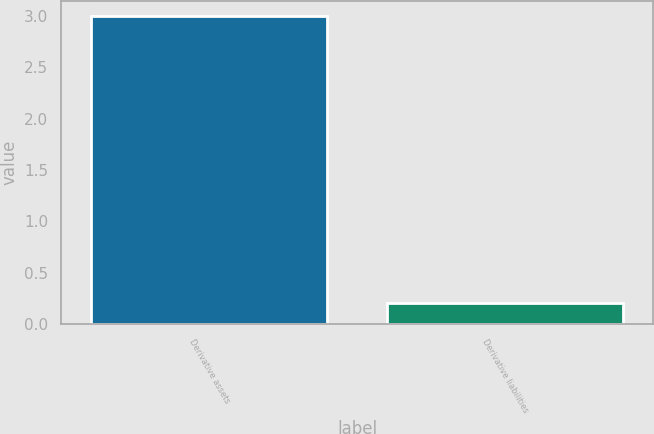<chart> <loc_0><loc_0><loc_500><loc_500><bar_chart><fcel>Derivative assets<fcel>Derivative liabilities<nl><fcel>3<fcel>0.2<nl></chart> 